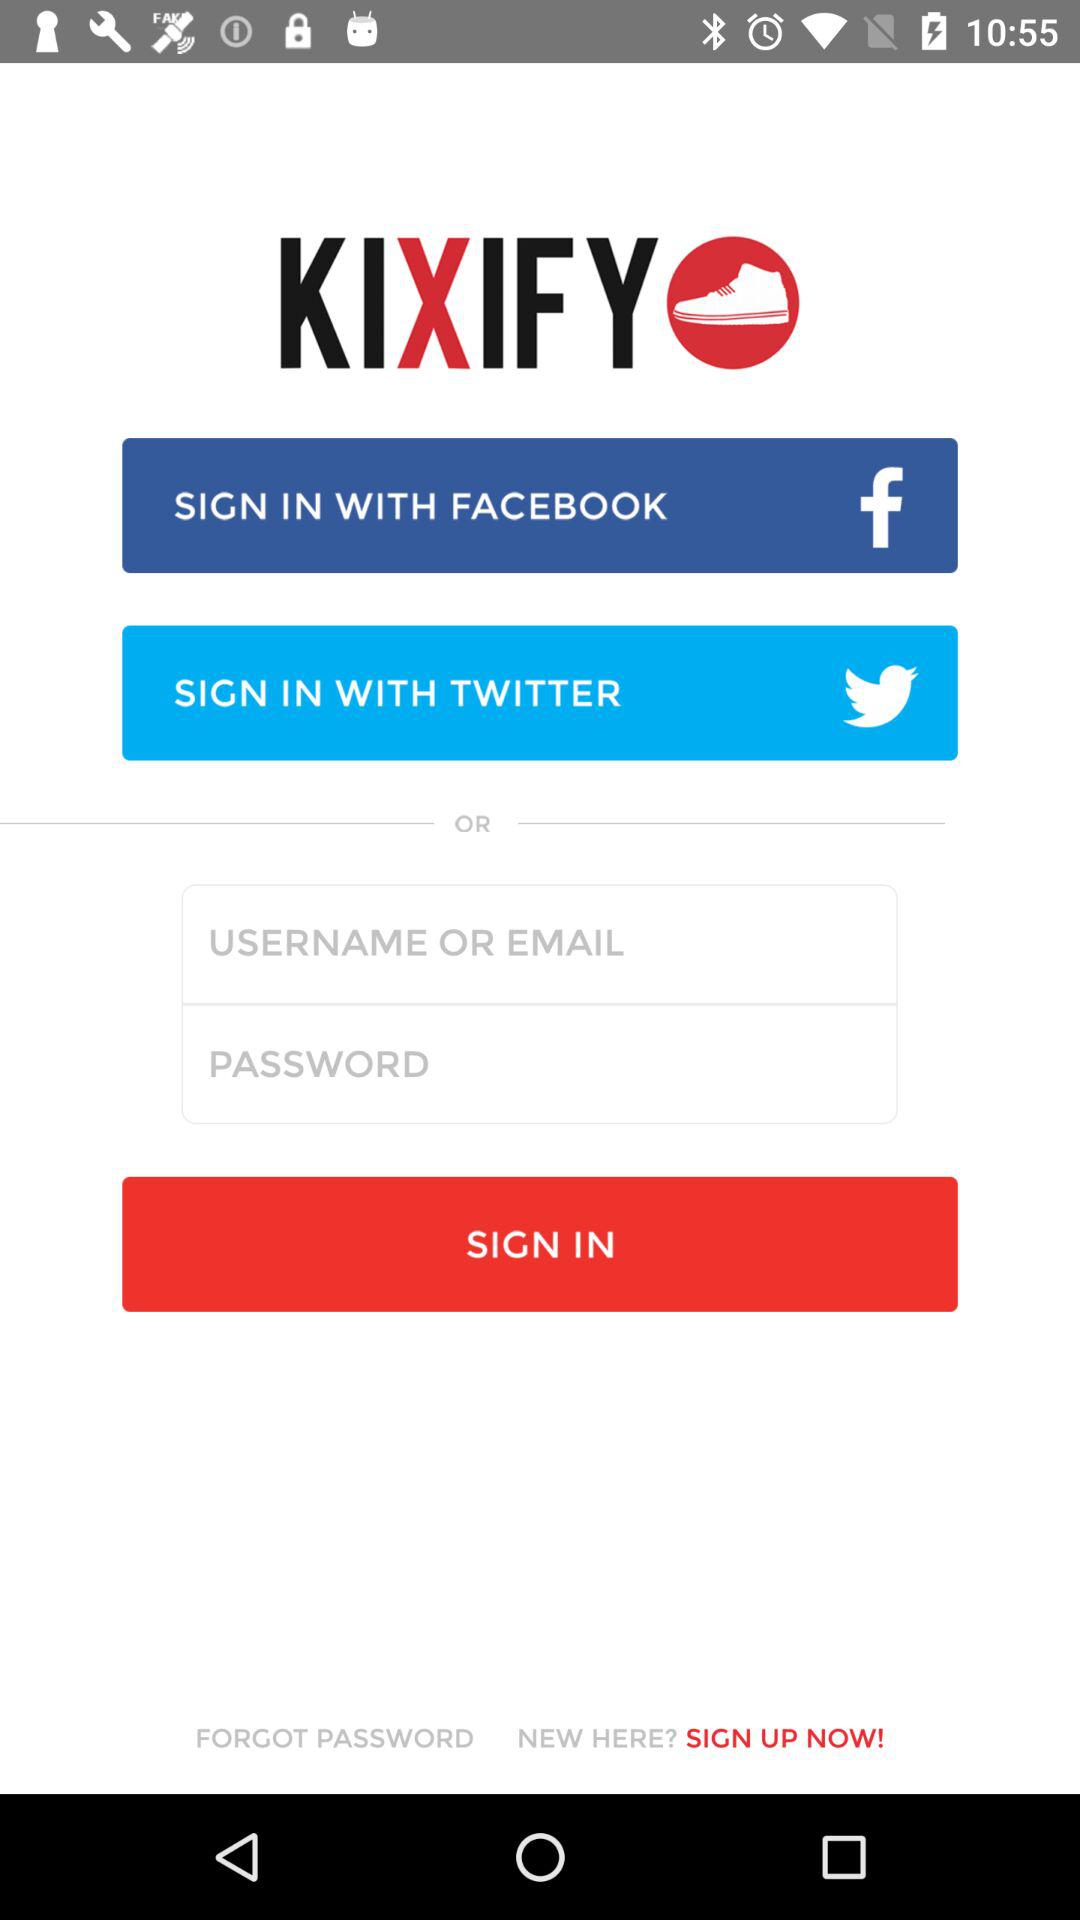What is the name of the application? The name of the application is "KIXIFY". 